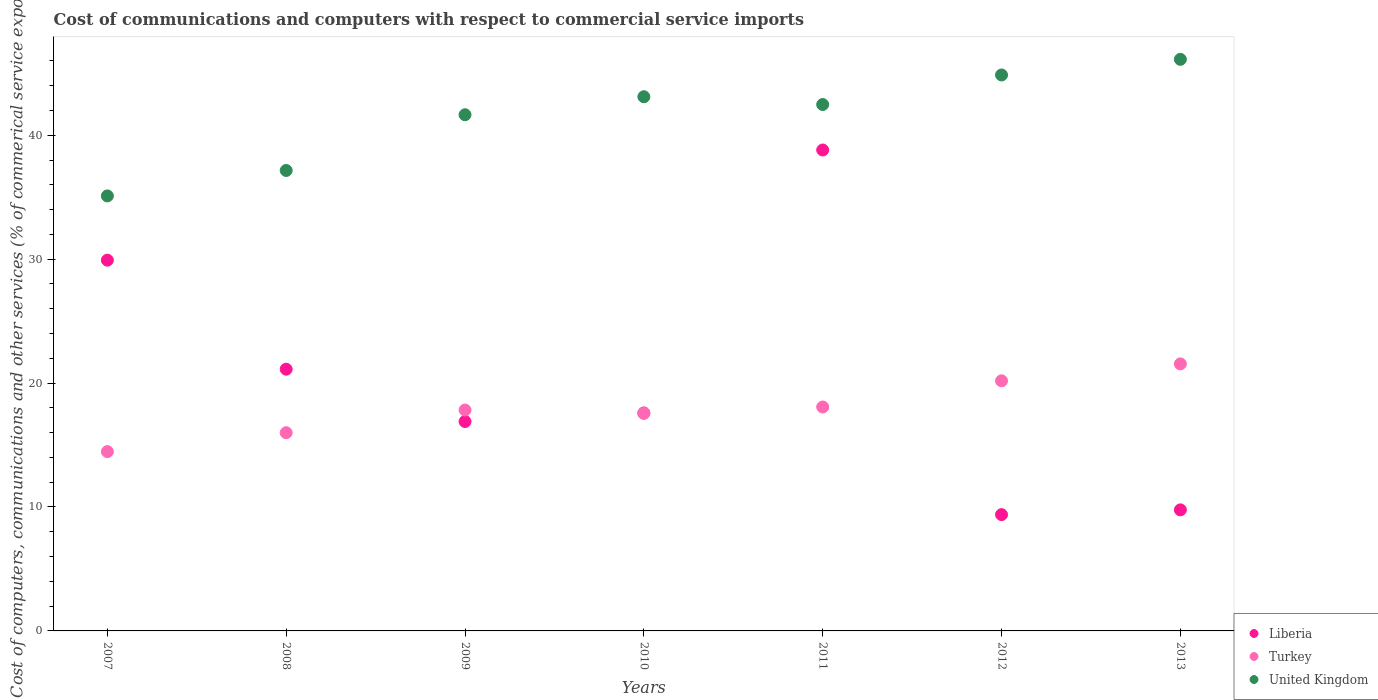Is the number of dotlines equal to the number of legend labels?
Your answer should be compact. Yes. What is the cost of communications and computers in Turkey in 2010?
Your answer should be very brief. 17.56. Across all years, what is the maximum cost of communications and computers in Liberia?
Your answer should be very brief. 38.81. Across all years, what is the minimum cost of communications and computers in Turkey?
Your response must be concise. 14.47. What is the total cost of communications and computers in Turkey in the graph?
Ensure brevity in your answer.  125.65. What is the difference between the cost of communications and computers in United Kingdom in 2007 and that in 2012?
Offer a very short reply. -9.76. What is the difference between the cost of communications and computers in Turkey in 2011 and the cost of communications and computers in United Kingdom in 2009?
Provide a succinct answer. -23.58. What is the average cost of communications and computers in Turkey per year?
Provide a short and direct response. 17.95. In the year 2007, what is the difference between the cost of communications and computers in Turkey and cost of communications and computers in Liberia?
Give a very brief answer. -15.45. What is the ratio of the cost of communications and computers in Turkey in 2010 to that in 2013?
Your response must be concise. 0.81. Is the cost of communications and computers in Turkey in 2007 less than that in 2012?
Provide a short and direct response. Yes. Is the difference between the cost of communications and computers in Turkey in 2010 and 2011 greater than the difference between the cost of communications and computers in Liberia in 2010 and 2011?
Offer a very short reply. Yes. What is the difference between the highest and the second highest cost of communications and computers in United Kingdom?
Offer a very short reply. 1.26. What is the difference between the highest and the lowest cost of communications and computers in Turkey?
Keep it short and to the point. 7.08. Is the cost of communications and computers in Liberia strictly greater than the cost of communications and computers in Turkey over the years?
Your answer should be very brief. No. Is the cost of communications and computers in Turkey strictly less than the cost of communications and computers in United Kingdom over the years?
Offer a terse response. Yes. How many dotlines are there?
Keep it short and to the point. 3. What is the difference between two consecutive major ticks on the Y-axis?
Provide a succinct answer. 10. What is the title of the graph?
Make the answer very short. Cost of communications and computers with respect to commercial service imports. What is the label or title of the Y-axis?
Provide a short and direct response. Cost of computers, communications and other services (% of commerical service exports). What is the Cost of computers, communications and other services (% of commerical service exports) of Liberia in 2007?
Your answer should be very brief. 29.92. What is the Cost of computers, communications and other services (% of commerical service exports) in Turkey in 2007?
Your answer should be compact. 14.47. What is the Cost of computers, communications and other services (% of commerical service exports) of United Kingdom in 2007?
Provide a succinct answer. 35.1. What is the Cost of computers, communications and other services (% of commerical service exports) of Liberia in 2008?
Keep it short and to the point. 21.12. What is the Cost of computers, communications and other services (% of commerical service exports) of Turkey in 2008?
Your answer should be very brief. 16. What is the Cost of computers, communications and other services (% of commerical service exports) of United Kingdom in 2008?
Make the answer very short. 37.16. What is the Cost of computers, communications and other services (% of commerical service exports) of Liberia in 2009?
Keep it short and to the point. 16.9. What is the Cost of computers, communications and other services (% of commerical service exports) in Turkey in 2009?
Give a very brief answer. 17.83. What is the Cost of computers, communications and other services (% of commerical service exports) in United Kingdom in 2009?
Keep it short and to the point. 41.65. What is the Cost of computers, communications and other services (% of commerical service exports) in Liberia in 2010?
Keep it short and to the point. 17.59. What is the Cost of computers, communications and other services (% of commerical service exports) in Turkey in 2010?
Provide a succinct answer. 17.56. What is the Cost of computers, communications and other services (% of commerical service exports) in United Kingdom in 2010?
Your answer should be very brief. 43.11. What is the Cost of computers, communications and other services (% of commerical service exports) in Liberia in 2011?
Your answer should be compact. 38.81. What is the Cost of computers, communications and other services (% of commerical service exports) in Turkey in 2011?
Your response must be concise. 18.07. What is the Cost of computers, communications and other services (% of commerical service exports) of United Kingdom in 2011?
Your answer should be very brief. 42.48. What is the Cost of computers, communications and other services (% of commerical service exports) in Liberia in 2012?
Provide a succinct answer. 9.38. What is the Cost of computers, communications and other services (% of commerical service exports) in Turkey in 2012?
Your answer should be very brief. 20.18. What is the Cost of computers, communications and other services (% of commerical service exports) in United Kingdom in 2012?
Offer a terse response. 44.86. What is the Cost of computers, communications and other services (% of commerical service exports) of Liberia in 2013?
Provide a short and direct response. 9.77. What is the Cost of computers, communications and other services (% of commerical service exports) in Turkey in 2013?
Your response must be concise. 21.55. What is the Cost of computers, communications and other services (% of commerical service exports) of United Kingdom in 2013?
Provide a succinct answer. 46.12. Across all years, what is the maximum Cost of computers, communications and other services (% of commerical service exports) of Liberia?
Your answer should be very brief. 38.81. Across all years, what is the maximum Cost of computers, communications and other services (% of commerical service exports) in Turkey?
Your answer should be compact. 21.55. Across all years, what is the maximum Cost of computers, communications and other services (% of commerical service exports) in United Kingdom?
Offer a very short reply. 46.12. Across all years, what is the minimum Cost of computers, communications and other services (% of commerical service exports) of Liberia?
Offer a terse response. 9.38. Across all years, what is the minimum Cost of computers, communications and other services (% of commerical service exports) in Turkey?
Offer a terse response. 14.47. Across all years, what is the minimum Cost of computers, communications and other services (% of commerical service exports) in United Kingdom?
Offer a very short reply. 35.1. What is the total Cost of computers, communications and other services (% of commerical service exports) in Liberia in the graph?
Make the answer very short. 143.49. What is the total Cost of computers, communications and other services (% of commerical service exports) in Turkey in the graph?
Keep it short and to the point. 125.65. What is the total Cost of computers, communications and other services (% of commerical service exports) in United Kingdom in the graph?
Provide a short and direct response. 290.48. What is the difference between the Cost of computers, communications and other services (% of commerical service exports) in Liberia in 2007 and that in 2008?
Offer a very short reply. 8.8. What is the difference between the Cost of computers, communications and other services (% of commerical service exports) in Turkey in 2007 and that in 2008?
Keep it short and to the point. -1.52. What is the difference between the Cost of computers, communications and other services (% of commerical service exports) of United Kingdom in 2007 and that in 2008?
Your answer should be compact. -2.05. What is the difference between the Cost of computers, communications and other services (% of commerical service exports) of Liberia in 2007 and that in 2009?
Ensure brevity in your answer.  13.02. What is the difference between the Cost of computers, communications and other services (% of commerical service exports) of Turkey in 2007 and that in 2009?
Provide a succinct answer. -3.35. What is the difference between the Cost of computers, communications and other services (% of commerical service exports) of United Kingdom in 2007 and that in 2009?
Your answer should be compact. -6.55. What is the difference between the Cost of computers, communications and other services (% of commerical service exports) of Liberia in 2007 and that in 2010?
Your response must be concise. 12.33. What is the difference between the Cost of computers, communications and other services (% of commerical service exports) in Turkey in 2007 and that in 2010?
Your response must be concise. -3.08. What is the difference between the Cost of computers, communications and other services (% of commerical service exports) in United Kingdom in 2007 and that in 2010?
Provide a succinct answer. -8. What is the difference between the Cost of computers, communications and other services (% of commerical service exports) in Liberia in 2007 and that in 2011?
Ensure brevity in your answer.  -8.89. What is the difference between the Cost of computers, communications and other services (% of commerical service exports) in Turkey in 2007 and that in 2011?
Provide a short and direct response. -3.6. What is the difference between the Cost of computers, communications and other services (% of commerical service exports) in United Kingdom in 2007 and that in 2011?
Make the answer very short. -7.38. What is the difference between the Cost of computers, communications and other services (% of commerical service exports) in Liberia in 2007 and that in 2012?
Ensure brevity in your answer.  20.53. What is the difference between the Cost of computers, communications and other services (% of commerical service exports) in Turkey in 2007 and that in 2012?
Keep it short and to the point. -5.71. What is the difference between the Cost of computers, communications and other services (% of commerical service exports) of United Kingdom in 2007 and that in 2012?
Make the answer very short. -9.76. What is the difference between the Cost of computers, communications and other services (% of commerical service exports) in Liberia in 2007 and that in 2013?
Provide a succinct answer. 20.15. What is the difference between the Cost of computers, communications and other services (% of commerical service exports) in Turkey in 2007 and that in 2013?
Offer a very short reply. -7.08. What is the difference between the Cost of computers, communications and other services (% of commerical service exports) of United Kingdom in 2007 and that in 2013?
Make the answer very short. -11.02. What is the difference between the Cost of computers, communications and other services (% of commerical service exports) in Liberia in 2008 and that in 2009?
Provide a succinct answer. 4.22. What is the difference between the Cost of computers, communications and other services (% of commerical service exports) in Turkey in 2008 and that in 2009?
Give a very brief answer. -1.83. What is the difference between the Cost of computers, communications and other services (% of commerical service exports) in United Kingdom in 2008 and that in 2009?
Your answer should be compact. -4.5. What is the difference between the Cost of computers, communications and other services (% of commerical service exports) of Liberia in 2008 and that in 2010?
Ensure brevity in your answer.  3.53. What is the difference between the Cost of computers, communications and other services (% of commerical service exports) of Turkey in 2008 and that in 2010?
Your answer should be very brief. -1.56. What is the difference between the Cost of computers, communications and other services (% of commerical service exports) of United Kingdom in 2008 and that in 2010?
Your answer should be very brief. -5.95. What is the difference between the Cost of computers, communications and other services (% of commerical service exports) in Liberia in 2008 and that in 2011?
Your answer should be compact. -17.69. What is the difference between the Cost of computers, communications and other services (% of commerical service exports) in Turkey in 2008 and that in 2011?
Ensure brevity in your answer.  -2.07. What is the difference between the Cost of computers, communications and other services (% of commerical service exports) of United Kingdom in 2008 and that in 2011?
Keep it short and to the point. -5.32. What is the difference between the Cost of computers, communications and other services (% of commerical service exports) of Liberia in 2008 and that in 2012?
Provide a succinct answer. 11.74. What is the difference between the Cost of computers, communications and other services (% of commerical service exports) of Turkey in 2008 and that in 2012?
Your answer should be compact. -4.19. What is the difference between the Cost of computers, communications and other services (% of commerical service exports) of United Kingdom in 2008 and that in 2012?
Give a very brief answer. -7.71. What is the difference between the Cost of computers, communications and other services (% of commerical service exports) in Liberia in 2008 and that in 2013?
Ensure brevity in your answer.  11.35. What is the difference between the Cost of computers, communications and other services (% of commerical service exports) in Turkey in 2008 and that in 2013?
Offer a very short reply. -5.55. What is the difference between the Cost of computers, communications and other services (% of commerical service exports) of United Kingdom in 2008 and that in 2013?
Give a very brief answer. -8.97. What is the difference between the Cost of computers, communications and other services (% of commerical service exports) of Liberia in 2009 and that in 2010?
Your answer should be compact. -0.69. What is the difference between the Cost of computers, communications and other services (% of commerical service exports) of Turkey in 2009 and that in 2010?
Keep it short and to the point. 0.27. What is the difference between the Cost of computers, communications and other services (% of commerical service exports) of United Kingdom in 2009 and that in 2010?
Offer a terse response. -1.45. What is the difference between the Cost of computers, communications and other services (% of commerical service exports) of Liberia in 2009 and that in 2011?
Give a very brief answer. -21.91. What is the difference between the Cost of computers, communications and other services (% of commerical service exports) of Turkey in 2009 and that in 2011?
Offer a very short reply. -0.24. What is the difference between the Cost of computers, communications and other services (% of commerical service exports) in United Kingdom in 2009 and that in 2011?
Ensure brevity in your answer.  -0.83. What is the difference between the Cost of computers, communications and other services (% of commerical service exports) in Liberia in 2009 and that in 2012?
Your answer should be very brief. 7.51. What is the difference between the Cost of computers, communications and other services (% of commerical service exports) of Turkey in 2009 and that in 2012?
Your response must be concise. -2.36. What is the difference between the Cost of computers, communications and other services (% of commerical service exports) of United Kingdom in 2009 and that in 2012?
Keep it short and to the point. -3.21. What is the difference between the Cost of computers, communications and other services (% of commerical service exports) in Liberia in 2009 and that in 2013?
Your response must be concise. 7.13. What is the difference between the Cost of computers, communications and other services (% of commerical service exports) of Turkey in 2009 and that in 2013?
Provide a succinct answer. -3.72. What is the difference between the Cost of computers, communications and other services (% of commerical service exports) of United Kingdom in 2009 and that in 2013?
Your answer should be compact. -4.47. What is the difference between the Cost of computers, communications and other services (% of commerical service exports) in Liberia in 2010 and that in 2011?
Keep it short and to the point. -21.22. What is the difference between the Cost of computers, communications and other services (% of commerical service exports) of Turkey in 2010 and that in 2011?
Your answer should be very brief. -0.51. What is the difference between the Cost of computers, communications and other services (% of commerical service exports) in United Kingdom in 2010 and that in 2011?
Offer a terse response. 0.63. What is the difference between the Cost of computers, communications and other services (% of commerical service exports) in Liberia in 2010 and that in 2012?
Keep it short and to the point. 8.21. What is the difference between the Cost of computers, communications and other services (% of commerical service exports) of Turkey in 2010 and that in 2012?
Your answer should be compact. -2.63. What is the difference between the Cost of computers, communications and other services (% of commerical service exports) in United Kingdom in 2010 and that in 2012?
Make the answer very short. -1.76. What is the difference between the Cost of computers, communications and other services (% of commerical service exports) in Liberia in 2010 and that in 2013?
Keep it short and to the point. 7.82. What is the difference between the Cost of computers, communications and other services (% of commerical service exports) in Turkey in 2010 and that in 2013?
Provide a succinct answer. -3.99. What is the difference between the Cost of computers, communications and other services (% of commerical service exports) of United Kingdom in 2010 and that in 2013?
Your answer should be compact. -3.02. What is the difference between the Cost of computers, communications and other services (% of commerical service exports) of Liberia in 2011 and that in 2012?
Give a very brief answer. 29.42. What is the difference between the Cost of computers, communications and other services (% of commerical service exports) in Turkey in 2011 and that in 2012?
Provide a short and direct response. -2.11. What is the difference between the Cost of computers, communications and other services (% of commerical service exports) of United Kingdom in 2011 and that in 2012?
Keep it short and to the point. -2.38. What is the difference between the Cost of computers, communications and other services (% of commerical service exports) of Liberia in 2011 and that in 2013?
Keep it short and to the point. 29.04. What is the difference between the Cost of computers, communications and other services (% of commerical service exports) in Turkey in 2011 and that in 2013?
Give a very brief answer. -3.48. What is the difference between the Cost of computers, communications and other services (% of commerical service exports) of United Kingdom in 2011 and that in 2013?
Give a very brief answer. -3.65. What is the difference between the Cost of computers, communications and other services (% of commerical service exports) of Liberia in 2012 and that in 2013?
Make the answer very short. -0.39. What is the difference between the Cost of computers, communications and other services (% of commerical service exports) of Turkey in 2012 and that in 2013?
Your answer should be compact. -1.37. What is the difference between the Cost of computers, communications and other services (% of commerical service exports) of United Kingdom in 2012 and that in 2013?
Your answer should be very brief. -1.26. What is the difference between the Cost of computers, communications and other services (% of commerical service exports) in Liberia in 2007 and the Cost of computers, communications and other services (% of commerical service exports) in Turkey in 2008?
Provide a short and direct response. 13.92. What is the difference between the Cost of computers, communications and other services (% of commerical service exports) in Liberia in 2007 and the Cost of computers, communications and other services (% of commerical service exports) in United Kingdom in 2008?
Keep it short and to the point. -7.24. What is the difference between the Cost of computers, communications and other services (% of commerical service exports) in Turkey in 2007 and the Cost of computers, communications and other services (% of commerical service exports) in United Kingdom in 2008?
Offer a terse response. -22.68. What is the difference between the Cost of computers, communications and other services (% of commerical service exports) of Liberia in 2007 and the Cost of computers, communications and other services (% of commerical service exports) of Turkey in 2009?
Your response must be concise. 12.09. What is the difference between the Cost of computers, communications and other services (% of commerical service exports) of Liberia in 2007 and the Cost of computers, communications and other services (% of commerical service exports) of United Kingdom in 2009?
Make the answer very short. -11.74. What is the difference between the Cost of computers, communications and other services (% of commerical service exports) of Turkey in 2007 and the Cost of computers, communications and other services (% of commerical service exports) of United Kingdom in 2009?
Make the answer very short. -27.18. What is the difference between the Cost of computers, communications and other services (% of commerical service exports) of Liberia in 2007 and the Cost of computers, communications and other services (% of commerical service exports) of Turkey in 2010?
Offer a terse response. 12.36. What is the difference between the Cost of computers, communications and other services (% of commerical service exports) of Liberia in 2007 and the Cost of computers, communications and other services (% of commerical service exports) of United Kingdom in 2010?
Give a very brief answer. -13.19. What is the difference between the Cost of computers, communications and other services (% of commerical service exports) of Turkey in 2007 and the Cost of computers, communications and other services (% of commerical service exports) of United Kingdom in 2010?
Your response must be concise. -28.64. What is the difference between the Cost of computers, communications and other services (% of commerical service exports) in Liberia in 2007 and the Cost of computers, communications and other services (% of commerical service exports) in Turkey in 2011?
Provide a succinct answer. 11.85. What is the difference between the Cost of computers, communications and other services (% of commerical service exports) in Liberia in 2007 and the Cost of computers, communications and other services (% of commerical service exports) in United Kingdom in 2011?
Your response must be concise. -12.56. What is the difference between the Cost of computers, communications and other services (% of commerical service exports) of Turkey in 2007 and the Cost of computers, communications and other services (% of commerical service exports) of United Kingdom in 2011?
Offer a terse response. -28.01. What is the difference between the Cost of computers, communications and other services (% of commerical service exports) of Liberia in 2007 and the Cost of computers, communications and other services (% of commerical service exports) of Turkey in 2012?
Keep it short and to the point. 9.73. What is the difference between the Cost of computers, communications and other services (% of commerical service exports) of Liberia in 2007 and the Cost of computers, communications and other services (% of commerical service exports) of United Kingdom in 2012?
Your response must be concise. -14.95. What is the difference between the Cost of computers, communications and other services (% of commerical service exports) of Turkey in 2007 and the Cost of computers, communications and other services (% of commerical service exports) of United Kingdom in 2012?
Make the answer very short. -30.39. What is the difference between the Cost of computers, communications and other services (% of commerical service exports) of Liberia in 2007 and the Cost of computers, communications and other services (% of commerical service exports) of Turkey in 2013?
Your answer should be very brief. 8.37. What is the difference between the Cost of computers, communications and other services (% of commerical service exports) of Liberia in 2007 and the Cost of computers, communications and other services (% of commerical service exports) of United Kingdom in 2013?
Make the answer very short. -16.21. What is the difference between the Cost of computers, communications and other services (% of commerical service exports) in Turkey in 2007 and the Cost of computers, communications and other services (% of commerical service exports) in United Kingdom in 2013?
Your response must be concise. -31.65. What is the difference between the Cost of computers, communications and other services (% of commerical service exports) of Liberia in 2008 and the Cost of computers, communications and other services (% of commerical service exports) of Turkey in 2009?
Provide a short and direct response. 3.29. What is the difference between the Cost of computers, communications and other services (% of commerical service exports) in Liberia in 2008 and the Cost of computers, communications and other services (% of commerical service exports) in United Kingdom in 2009?
Provide a succinct answer. -20.53. What is the difference between the Cost of computers, communications and other services (% of commerical service exports) in Turkey in 2008 and the Cost of computers, communications and other services (% of commerical service exports) in United Kingdom in 2009?
Provide a succinct answer. -25.66. What is the difference between the Cost of computers, communications and other services (% of commerical service exports) of Liberia in 2008 and the Cost of computers, communications and other services (% of commerical service exports) of Turkey in 2010?
Give a very brief answer. 3.56. What is the difference between the Cost of computers, communications and other services (% of commerical service exports) of Liberia in 2008 and the Cost of computers, communications and other services (% of commerical service exports) of United Kingdom in 2010?
Your response must be concise. -21.99. What is the difference between the Cost of computers, communications and other services (% of commerical service exports) of Turkey in 2008 and the Cost of computers, communications and other services (% of commerical service exports) of United Kingdom in 2010?
Provide a succinct answer. -27.11. What is the difference between the Cost of computers, communications and other services (% of commerical service exports) of Liberia in 2008 and the Cost of computers, communications and other services (% of commerical service exports) of Turkey in 2011?
Make the answer very short. 3.05. What is the difference between the Cost of computers, communications and other services (% of commerical service exports) of Liberia in 2008 and the Cost of computers, communications and other services (% of commerical service exports) of United Kingdom in 2011?
Your answer should be compact. -21.36. What is the difference between the Cost of computers, communications and other services (% of commerical service exports) of Turkey in 2008 and the Cost of computers, communications and other services (% of commerical service exports) of United Kingdom in 2011?
Make the answer very short. -26.48. What is the difference between the Cost of computers, communications and other services (% of commerical service exports) of Liberia in 2008 and the Cost of computers, communications and other services (% of commerical service exports) of Turkey in 2012?
Give a very brief answer. 0.94. What is the difference between the Cost of computers, communications and other services (% of commerical service exports) in Liberia in 2008 and the Cost of computers, communications and other services (% of commerical service exports) in United Kingdom in 2012?
Offer a very short reply. -23.74. What is the difference between the Cost of computers, communications and other services (% of commerical service exports) in Turkey in 2008 and the Cost of computers, communications and other services (% of commerical service exports) in United Kingdom in 2012?
Your response must be concise. -28.87. What is the difference between the Cost of computers, communications and other services (% of commerical service exports) in Liberia in 2008 and the Cost of computers, communications and other services (% of commerical service exports) in Turkey in 2013?
Your answer should be compact. -0.43. What is the difference between the Cost of computers, communications and other services (% of commerical service exports) in Liberia in 2008 and the Cost of computers, communications and other services (% of commerical service exports) in United Kingdom in 2013?
Your response must be concise. -25. What is the difference between the Cost of computers, communications and other services (% of commerical service exports) in Turkey in 2008 and the Cost of computers, communications and other services (% of commerical service exports) in United Kingdom in 2013?
Your response must be concise. -30.13. What is the difference between the Cost of computers, communications and other services (% of commerical service exports) in Liberia in 2009 and the Cost of computers, communications and other services (% of commerical service exports) in Turkey in 2010?
Ensure brevity in your answer.  -0.66. What is the difference between the Cost of computers, communications and other services (% of commerical service exports) in Liberia in 2009 and the Cost of computers, communications and other services (% of commerical service exports) in United Kingdom in 2010?
Your answer should be very brief. -26.21. What is the difference between the Cost of computers, communications and other services (% of commerical service exports) of Turkey in 2009 and the Cost of computers, communications and other services (% of commerical service exports) of United Kingdom in 2010?
Provide a succinct answer. -25.28. What is the difference between the Cost of computers, communications and other services (% of commerical service exports) in Liberia in 2009 and the Cost of computers, communications and other services (% of commerical service exports) in Turkey in 2011?
Your response must be concise. -1.17. What is the difference between the Cost of computers, communications and other services (% of commerical service exports) in Liberia in 2009 and the Cost of computers, communications and other services (% of commerical service exports) in United Kingdom in 2011?
Your answer should be very brief. -25.58. What is the difference between the Cost of computers, communications and other services (% of commerical service exports) in Turkey in 2009 and the Cost of computers, communications and other services (% of commerical service exports) in United Kingdom in 2011?
Give a very brief answer. -24.65. What is the difference between the Cost of computers, communications and other services (% of commerical service exports) in Liberia in 2009 and the Cost of computers, communications and other services (% of commerical service exports) in Turkey in 2012?
Your response must be concise. -3.28. What is the difference between the Cost of computers, communications and other services (% of commerical service exports) of Liberia in 2009 and the Cost of computers, communications and other services (% of commerical service exports) of United Kingdom in 2012?
Your response must be concise. -27.96. What is the difference between the Cost of computers, communications and other services (% of commerical service exports) in Turkey in 2009 and the Cost of computers, communications and other services (% of commerical service exports) in United Kingdom in 2012?
Keep it short and to the point. -27.04. What is the difference between the Cost of computers, communications and other services (% of commerical service exports) of Liberia in 2009 and the Cost of computers, communications and other services (% of commerical service exports) of Turkey in 2013?
Your response must be concise. -4.65. What is the difference between the Cost of computers, communications and other services (% of commerical service exports) in Liberia in 2009 and the Cost of computers, communications and other services (% of commerical service exports) in United Kingdom in 2013?
Provide a short and direct response. -29.23. What is the difference between the Cost of computers, communications and other services (% of commerical service exports) of Turkey in 2009 and the Cost of computers, communications and other services (% of commerical service exports) of United Kingdom in 2013?
Provide a short and direct response. -28.3. What is the difference between the Cost of computers, communications and other services (% of commerical service exports) in Liberia in 2010 and the Cost of computers, communications and other services (% of commerical service exports) in Turkey in 2011?
Make the answer very short. -0.48. What is the difference between the Cost of computers, communications and other services (% of commerical service exports) in Liberia in 2010 and the Cost of computers, communications and other services (% of commerical service exports) in United Kingdom in 2011?
Make the answer very short. -24.89. What is the difference between the Cost of computers, communications and other services (% of commerical service exports) in Turkey in 2010 and the Cost of computers, communications and other services (% of commerical service exports) in United Kingdom in 2011?
Provide a succinct answer. -24.92. What is the difference between the Cost of computers, communications and other services (% of commerical service exports) of Liberia in 2010 and the Cost of computers, communications and other services (% of commerical service exports) of Turkey in 2012?
Keep it short and to the point. -2.59. What is the difference between the Cost of computers, communications and other services (% of commerical service exports) in Liberia in 2010 and the Cost of computers, communications and other services (% of commerical service exports) in United Kingdom in 2012?
Ensure brevity in your answer.  -27.27. What is the difference between the Cost of computers, communications and other services (% of commerical service exports) in Turkey in 2010 and the Cost of computers, communications and other services (% of commerical service exports) in United Kingdom in 2012?
Offer a very short reply. -27.31. What is the difference between the Cost of computers, communications and other services (% of commerical service exports) in Liberia in 2010 and the Cost of computers, communications and other services (% of commerical service exports) in Turkey in 2013?
Your response must be concise. -3.96. What is the difference between the Cost of computers, communications and other services (% of commerical service exports) of Liberia in 2010 and the Cost of computers, communications and other services (% of commerical service exports) of United Kingdom in 2013?
Offer a very short reply. -28.54. What is the difference between the Cost of computers, communications and other services (% of commerical service exports) of Turkey in 2010 and the Cost of computers, communications and other services (% of commerical service exports) of United Kingdom in 2013?
Provide a succinct answer. -28.57. What is the difference between the Cost of computers, communications and other services (% of commerical service exports) of Liberia in 2011 and the Cost of computers, communications and other services (% of commerical service exports) of Turkey in 2012?
Offer a terse response. 18.63. What is the difference between the Cost of computers, communications and other services (% of commerical service exports) in Liberia in 2011 and the Cost of computers, communications and other services (% of commerical service exports) in United Kingdom in 2012?
Your answer should be very brief. -6.05. What is the difference between the Cost of computers, communications and other services (% of commerical service exports) in Turkey in 2011 and the Cost of computers, communications and other services (% of commerical service exports) in United Kingdom in 2012?
Offer a terse response. -26.79. What is the difference between the Cost of computers, communications and other services (% of commerical service exports) in Liberia in 2011 and the Cost of computers, communications and other services (% of commerical service exports) in Turkey in 2013?
Provide a succinct answer. 17.26. What is the difference between the Cost of computers, communications and other services (% of commerical service exports) in Liberia in 2011 and the Cost of computers, communications and other services (% of commerical service exports) in United Kingdom in 2013?
Offer a very short reply. -7.32. What is the difference between the Cost of computers, communications and other services (% of commerical service exports) of Turkey in 2011 and the Cost of computers, communications and other services (% of commerical service exports) of United Kingdom in 2013?
Keep it short and to the point. -28.05. What is the difference between the Cost of computers, communications and other services (% of commerical service exports) of Liberia in 2012 and the Cost of computers, communications and other services (% of commerical service exports) of Turkey in 2013?
Ensure brevity in your answer.  -12.16. What is the difference between the Cost of computers, communications and other services (% of commerical service exports) in Liberia in 2012 and the Cost of computers, communications and other services (% of commerical service exports) in United Kingdom in 2013?
Offer a very short reply. -36.74. What is the difference between the Cost of computers, communications and other services (% of commerical service exports) in Turkey in 2012 and the Cost of computers, communications and other services (% of commerical service exports) in United Kingdom in 2013?
Offer a terse response. -25.94. What is the average Cost of computers, communications and other services (% of commerical service exports) in Liberia per year?
Your response must be concise. 20.5. What is the average Cost of computers, communications and other services (% of commerical service exports) in Turkey per year?
Your response must be concise. 17.95. What is the average Cost of computers, communications and other services (% of commerical service exports) of United Kingdom per year?
Keep it short and to the point. 41.5. In the year 2007, what is the difference between the Cost of computers, communications and other services (% of commerical service exports) of Liberia and Cost of computers, communications and other services (% of commerical service exports) of Turkey?
Ensure brevity in your answer.  15.45. In the year 2007, what is the difference between the Cost of computers, communications and other services (% of commerical service exports) of Liberia and Cost of computers, communications and other services (% of commerical service exports) of United Kingdom?
Give a very brief answer. -5.19. In the year 2007, what is the difference between the Cost of computers, communications and other services (% of commerical service exports) of Turkey and Cost of computers, communications and other services (% of commerical service exports) of United Kingdom?
Keep it short and to the point. -20.63. In the year 2008, what is the difference between the Cost of computers, communications and other services (% of commerical service exports) in Liberia and Cost of computers, communications and other services (% of commerical service exports) in Turkey?
Your response must be concise. 5.12. In the year 2008, what is the difference between the Cost of computers, communications and other services (% of commerical service exports) of Liberia and Cost of computers, communications and other services (% of commerical service exports) of United Kingdom?
Offer a very short reply. -16.04. In the year 2008, what is the difference between the Cost of computers, communications and other services (% of commerical service exports) of Turkey and Cost of computers, communications and other services (% of commerical service exports) of United Kingdom?
Offer a very short reply. -21.16. In the year 2009, what is the difference between the Cost of computers, communications and other services (% of commerical service exports) in Liberia and Cost of computers, communications and other services (% of commerical service exports) in Turkey?
Give a very brief answer. -0.93. In the year 2009, what is the difference between the Cost of computers, communications and other services (% of commerical service exports) in Liberia and Cost of computers, communications and other services (% of commerical service exports) in United Kingdom?
Your response must be concise. -24.75. In the year 2009, what is the difference between the Cost of computers, communications and other services (% of commerical service exports) in Turkey and Cost of computers, communications and other services (% of commerical service exports) in United Kingdom?
Your response must be concise. -23.83. In the year 2010, what is the difference between the Cost of computers, communications and other services (% of commerical service exports) of Liberia and Cost of computers, communications and other services (% of commerical service exports) of Turkey?
Give a very brief answer. 0.03. In the year 2010, what is the difference between the Cost of computers, communications and other services (% of commerical service exports) in Liberia and Cost of computers, communications and other services (% of commerical service exports) in United Kingdom?
Give a very brief answer. -25.52. In the year 2010, what is the difference between the Cost of computers, communications and other services (% of commerical service exports) of Turkey and Cost of computers, communications and other services (% of commerical service exports) of United Kingdom?
Your response must be concise. -25.55. In the year 2011, what is the difference between the Cost of computers, communications and other services (% of commerical service exports) of Liberia and Cost of computers, communications and other services (% of commerical service exports) of Turkey?
Offer a very short reply. 20.74. In the year 2011, what is the difference between the Cost of computers, communications and other services (% of commerical service exports) of Liberia and Cost of computers, communications and other services (% of commerical service exports) of United Kingdom?
Make the answer very short. -3.67. In the year 2011, what is the difference between the Cost of computers, communications and other services (% of commerical service exports) of Turkey and Cost of computers, communications and other services (% of commerical service exports) of United Kingdom?
Your response must be concise. -24.41. In the year 2012, what is the difference between the Cost of computers, communications and other services (% of commerical service exports) of Liberia and Cost of computers, communications and other services (% of commerical service exports) of Turkey?
Provide a succinct answer. -10.8. In the year 2012, what is the difference between the Cost of computers, communications and other services (% of commerical service exports) of Liberia and Cost of computers, communications and other services (% of commerical service exports) of United Kingdom?
Make the answer very short. -35.48. In the year 2012, what is the difference between the Cost of computers, communications and other services (% of commerical service exports) in Turkey and Cost of computers, communications and other services (% of commerical service exports) in United Kingdom?
Ensure brevity in your answer.  -24.68. In the year 2013, what is the difference between the Cost of computers, communications and other services (% of commerical service exports) of Liberia and Cost of computers, communications and other services (% of commerical service exports) of Turkey?
Offer a very short reply. -11.78. In the year 2013, what is the difference between the Cost of computers, communications and other services (% of commerical service exports) of Liberia and Cost of computers, communications and other services (% of commerical service exports) of United Kingdom?
Give a very brief answer. -36.35. In the year 2013, what is the difference between the Cost of computers, communications and other services (% of commerical service exports) of Turkey and Cost of computers, communications and other services (% of commerical service exports) of United Kingdom?
Ensure brevity in your answer.  -24.58. What is the ratio of the Cost of computers, communications and other services (% of commerical service exports) of Liberia in 2007 to that in 2008?
Make the answer very short. 1.42. What is the ratio of the Cost of computers, communications and other services (% of commerical service exports) of Turkey in 2007 to that in 2008?
Keep it short and to the point. 0.9. What is the ratio of the Cost of computers, communications and other services (% of commerical service exports) of United Kingdom in 2007 to that in 2008?
Offer a very short reply. 0.94. What is the ratio of the Cost of computers, communications and other services (% of commerical service exports) in Liberia in 2007 to that in 2009?
Your answer should be compact. 1.77. What is the ratio of the Cost of computers, communications and other services (% of commerical service exports) in Turkey in 2007 to that in 2009?
Give a very brief answer. 0.81. What is the ratio of the Cost of computers, communications and other services (% of commerical service exports) of United Kingdom in 2007 to that in 2009?
Provide a succinct answer. 0.84. What is the ratio of the Cost of computers, communications and other services (% of commerical service exports) of Liberia in 2007 to that in 2010?
Make the answer very short. 1.7. What is the ratio of the Cost of computers, communications and other services (% of commerical service exports) in Turkey in 2007 to that in 2010?
Your answer should be very brief. 0.82. What is the ratio of the Cost of computers, communications and other services (% of commerical service exports) in United Kingdom in 2007 to that in 2010?
Offer a terse response. 0.81. What is the ratio of the Cost of computers, communications and other services (% of commerical service exports) in Liberia in 2007 to that in 2011?
Offer a terse response. 0.77. What is the ratio of the Cost of computers, communications and other services (% of commerical service exports) in Turkey in 2007 to that in 2011?
Make the answer very short. 0.8. What is the ratio of the Cost of computers, communications and other services (% of commerical service exports) of United Kingdom in 2007 to that in 2011?
Keep it short and to the point. 0.83. What is the ratio of the Cost of computers, communications and other services (% of commerical service exports) of Liberia in 2007 to that in 2012?
Keep it short and to the point. 3.19. What is the ratio of the Cost of computers, communications and other services (% of commerical service exports) in Turkey in 2007 to that in 2012?
Provide a succinct answer. 0.72. What is the ratio of the Cost of computers, communications and other services (% of commerical service exports) of United Kingdom in 2007 to that in 2012?
Provide a short and direct response. 0.78. What is the ratio of the Cost of computers, communications and other services (% of commerical service exports) of Liberia in 2007 to that in 2013?
Your answer should be very brief. 3.06. What is the ratio of the Cost of computers, communications and other services (% of commerical service exports) of Turkey in 2007 to that in 2013?
Offer a terse response. 0.67. What is the ratio of the Cost of computers, communications and other services (% of commerical service exports) of United Kingdom in 2007 to that in 2013?
Make the answer very short. 0.76. What is the ratio of the Cost of computers, communications and other services (% of commerical service exports) in Liberia in 2008 to that in 2009?
Offer a terse response. 1.25. What is the ratio of the Cost of computers, communications and other services (% of commerical service exports) of Turkey in 2008 to that in 2009?
Provide a succinct answer. 0.9. What is the ratio of the Cost of computers, communications and other services (% of commerical service exports) of United Kingdom in 2008 to that in 2009?
Your response must be concise. 0.89. What is the ratio of the Cost of computers, communications and other services (% of commerical service exports) of Liberia in 2008 to that in 2010?
Offer a very short reply. 1.2. What is the ratio of the Cost of computers, communications and other services (% of commerical service exports) of Turkey in 2008 to that in 2010?
Keep it short and to the point. 0.91. What is the ratio of the Cost of computers, communications and other services (% of commerical service exports) of United Kingdom in 2008 to that in 2010?
Provide a succinct answer. 0.86. What is the ratio of the Cost of computers, communications and other services (% of commerical service exports) in Liberia in 2008 to that in 2011?
Offer a very short reply. 0.54. What is the ratio of the Cost of computers, communications and other services (% of commerical service exports) in Turkey in 2008 to that in 2011?
Keep it short and to the point. 0.89. What is the ratio of the Cost of computers, communications and other services (% of commerical service exports) in United Kingdom in 2008 to that in 2011?
Ensure brevity in your answer.  0.87. What is the ratio of the Cost of computers, communications and other services (% of commerical service exports) of Liberia in 2008 to that in 2012?
Offer a very short reply. 2.25. What is the ratio of the Cost of computers, communications and other services (% of commerical service exports) in Turkey in 2008 to that in 2012?
Provide a short and direct response. 0.79. What is the ratio of the Cost of computers, communications and other services (% of commerical service exports) in United Kingdom in 2008 to that in 2012?
Offer a terse response. 0.83. What is the ratio of the Cost of computers, communications and other services (% of commerical service exports) in Liberia in 2008 to that in 2013?
Ensure brevity in your answer.  2.16. What is the ratio of the Cost of computers, communications and other services (% of commerical service exports) in Turkey in 2008 to that in 2013?
Your answer should be very brief. 0.74. What is the ratio of the Cost of computers, communications and other services (% of commerical service exports) of United Kingdom in 2008 to that in 2013?
Provide a succinct answer. 0.81. What is the ratio of the Cost of computers, communications and other services (% of commerical service exports) of Liberia in 2009 to that in 2010?
Make the answer very short. 0.96. What is the ratio of the Cost of computers, communications and other services (% of commerical service exports) in Turkey in 2009 to that in 2010?
Your answer should be very brief. 1.02. What is the ratio of the Cost of computers, communications and other services (% of commerical service exports) of United Kingdom in 2009 to that in 2010?
Your answer should be compact. 0.97. What is the ratio of the Cost of computers, communications and other services (% of commerical service exports) of Liberia in 2009 to that in 2011?
Give a very brief answer. 0.44. What is the ratio of the Cost of computers, communications and other services (% of commerical service exports) of Turkey in 2009 to that in 2011?
Provide a succinct answer. 0.99. What is the ratio of the Cost of computers, communications and other services (% of commerical service exports) in United Kingdom in 2009 to that in 2011?
Provide a short and direct response. 0.98. What is the ratio of the Cost of computers, communications and other services (% of commerical service exports) in Liberia in 2009 to that in 2012?
Offer a very short reply. 1.8. What is the ratio of the Cost of computers, communications and other services (% of commerical service exports) of Turkey in 2009 to that in 2012?
Provide a succinct answer. 0.88. What is the ratio of the Cost of computers, communications and other services (% of commerical service exports) of United Kingdom in 2009 to that in 2012?
Keep it short and to the point. 0.93. What is the ratio of the Cost of computers, communications and other services (% of commerical service exports) of Liberia in 2009 to that in 2013?
Provide a short and direct response. 1.73. What is the ratio of the Cost of computers, communications and other services (% of commerical service exports) of Turkey in 2009 to that in 2013?
Provide a succinct answer. 0.83. What is the ratio of the Cost of computers, communications and other services (% of commerical service exports) in United Kingdom in 2009 to that in 2013?
Keep it short and to the point. 0.9. What is the ratio of the Cost of computers, communications and other services (% of commerical service exports) in Liberia in 2010 to that in 2011?
Provide a succinct answer. 0.45. What is the ratio of the Cost of computers, communications and other services (% of commerical service exports) of Turkey in 2010 to that in 2011?
Ensure brevity in your answer.  0.97. What is the ratio of the Cost of computers, communications and other services (% of commerical service exports) in United Kingdom in 2010 to that in 2011?
Offer a very short reply. 1.01. What is the ratio of the Cost of computers, communications and other services (% of commerical service exports) of Liberia in 2010 to that in 2012?
Provide a succinct answer. 1.87. What is the ratio of the Cost of computers, communications and other services (% of commerical service exports) of Turkey in 2010 to that in 2012?
Ensure brevity in your answer.  0.87. What is the ratio of the Cost of computers, communications and other services (% of commerical service exports) of United Kingdom in 2010 to that in 2012?
Provide a succinct answer. 0.96. What is the ratio of the Cost of computers, communications and other services (% of commerical service exports) of Liberia in 2010 to that in 2013?
Keep it short and to the point. 1.8. What is the ratio of the Cost of computers, communications and other services (% of commerical service exports) in Turkey in 2010 to that in 2013?
Keep it short and to the point. 0.81. What is the ratio of the Cost of computers, communications and other services (% of commerical service exports) of United Kingdom in 2010 to that in 2013?
Give a very brief answer. 0.93. What is the ratio of the Cost of computers, communications and other services (% of commerical service exports) of Liberia in 2011 to that in 2012?
Ensure brevity in your answer.  4.14. What is the ratio of the Cost of computers, communications and other services (% of commerical service exports) in Turkey in 2011 to that in 2012?
Your answer should be very brief. 0.9. What is the ratio of the Cost of computers, communications and other services (% of commerical service exports) in United Kingdom in 2011 to that in 2012?
Ensure brevity in your answer.  0.95. What is the ratio of the Cost of computers, communications and other services (% of commerical service exports) of Liberia in 2011 to that in 2013?
Offer a terse response. 3.97. What is the ratio of the Cost of computers, communications and other services (% of commerical service exports) in Turkey in 2011 to that in 2013?
Give a very brief answer. 0.84. What is the ratio of the Cost of computers, communications and other services (% of commerical service exports) of United Kingdom in 2011 to that in 2013?
Your response must be concise. 0.92. What is the ratio of the Cost of computers, communications and other services (% of commerical service exports) in Liberia in 2012 to that in 2013?
Offer a terse response. 0.96. What is the ratio of the Cost of computers, communications and other services (% of commerical service exports) in Turkey in 2012 to that in 2013?
Keep it short and to the point. 0.94. What is the ratio of the Cost of computers, communications and other services (% of commerical service exports) of United Kingdom in 2012 to that in 2013?
Ensure brevity in your answer.  0.97. What is the difference between the highest and the second highest Cost of computers, communications and other services (% of commerical service exports) in Liberia?
Offer a terse response. 8.89. What is the difference between the highest and the second highest Cost of computers, communications and other services (% of commerical service exports) in Turkey?
Ensure brevity in your answer.  1.37. What is the difference between the highest and the second highest Cost of computers, communications and other services (% of commerical service exports) of United Kingdom?
Offer a terse response. 1.26. What is the difference between the highest and the lowest Cost of computers, communications and other services (% of commerical service exports) in Liberia?
Make the answer very short. 29.42. What is the difference between the highest and the lowest Cost of computers, communications and other services (% of commerical service exports) in Turkey?
Keep it short and to the point. 7.08. What is the difference between the highest and the lowest Cost of computers, communications and other services (% of commerical service exports) in United Kingdom?
Provide a short and direct response. 11.02. 